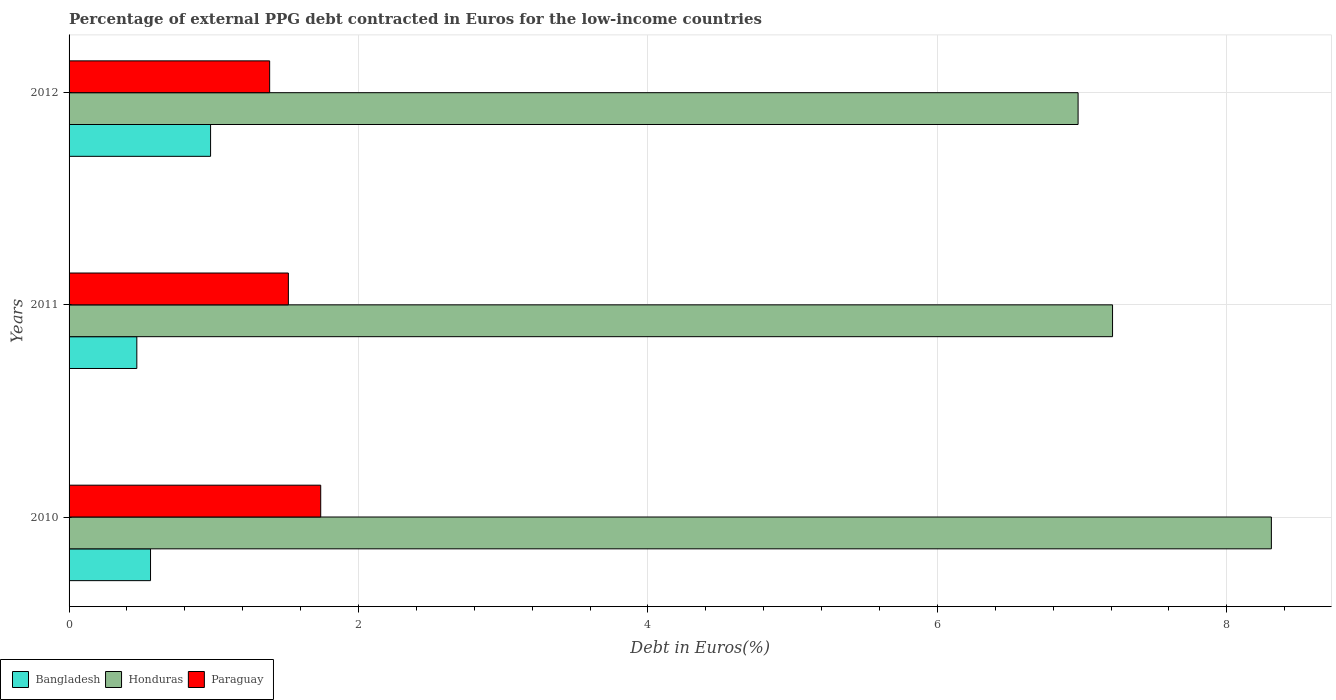How many different coloured bars are there?
Your response must be concise. 3. How many groups of bars are there?
Provide a succinct answer. 3. How many bars are there on the 2nd tick from the top?
Your response must be concise. 3. How many bars are there on the 1st tick from the bottom?
Your response must be concise. 3. What is the percentage of external PPG debt contracted in Euros in Honduras in 2010?
Offer a terse response. 8.31. Across all years, what is the maximum percentage of external PPG debt contracted in Euros in Bangladesh?
Make the answer very short. 0.98. Across all years, what is the minimum percentage of external PPG debt contracted in Euros in Honduras?
Keep it short and to the point. 6.97. What is the total percentage of external PPG debt contracted in Euros in Paraguay in the graph?
Your response must be concise. 4.64. What is the difference between the percentage of external PPG debt contracted in Euros in Honduras in 2011 and that in 2012?
Your response must be concise. 0.24. What is the difference between the percentage of external PPG debt contracted in Euros in Paraguay in 2011 and the percentage of external PPG debt contracted in Euros in Honduras in 2012?
Ensure brevity in your answer.  -5.46. What is the average percentage of external PPG debt contracted in Euros in Paraguay per year?
Offer a very short reply. 1.55. In the year 2012, what is the difference between the percentage of external PPG debt contracted in Euros in Bangladesh and percentage of external PPG debt contracted in Euros in Paraguay?
Your answer should be compact. -0.41. What is the ratio of the percentage of external PPG debt contracted in Euros in Paraguay in 2011 to that in 2012?
Give a very brief answer. 1.09. Is the percentage of external PPG debt contracted in Euros in Bangladesh in 2011 less than that in 2012?
Give a very brief answer. Yes. Is the difference between the percentage of external PPG debt contracted in Euros in Bangladesh in 2011 and 2012 greater than the difference between the percentage of external PPG debt contracted in Euros in Paraguay in 2011 and 2012?
Your answer should be compact. No. What is the difference between the highest and the second highest percentage of external PPG debt contracted in Euros in Paraguay?
Give a very brief answer. 0.22. What is the difference between the highest and the lowest percentage of external PPG debt contracted in Euros in Paraguay?
Keep it short and to the point. 0.35. Is the sum of the percentage of external PPG debt contracted in Euros in Paraguay in 2011 and 2012 greater than the maximum percentage of external PPG debt contracted in Euros in Honduras across all years?
Offer a very short reply. No. What does the 1st bar from the top in 2012 represents?
Your response must be concise. Paraguay. What does the 1st bar from the bottom in 2012 represents?
Provide a succinct answer. Bangladesh. Is it the case that in every year, the sum of the percentage of external PPG debt contracted in Euros in Paraguay and percentage of external PPG debt contracted in Euros in Bangladesh is greater than the percentage of external PPG debt contracted in Euros in Honduras?
Offer a very short reply. No. How many years are there in the graph?
Make the answer very short. 3. What is the difference between two consecutive major ticks on the X-axis?
Provide a succinct answer. 2. Where does the legend appear in the graph?
Your answer should be very brief. Bottom left. How many legend labels are there?
Offer a terse response. 3. How are the legend labels stacked?
Ensure brevity in your answer.  Horizontal. What is the title of the graph?
Your answer should be very brief. Percentage of external PPG debt contracted in Euros for the low-income countries. What is the label or title of the X-axis?
Make the answer very short. Debt in Euros(%). What is the label or title of the Y-axis?
Your answer should be compact. Years. What is the Debt in Euros(%) in Bangladesh in 2010?
Make the answer very short. 0.56. What is the Debt in Euros(%) of Honduras in 2010?
Your response must be concise. 8.31. What is the Debt in Euros(%) of Paraguay in 2010?
Your response must be concise. 1.74. What is the Debt in Euros(%) of Bangladesh in 2011?
Offer a very short reply. 0.47. What is the Debt in Euros(%) in Honduras in 2011?
Provide a succinct answer. 7.21. What is the Debt in Euros(%) in Paraguay in 2011?
Offer a terse response. 1.52. What is the Debt in Euros(%) in Bangladesh in 2012?
Make the answer very short. 0.98. What is the Debt in Euros(%) of Honduras in 2012?
Offer a terse response. 6.97. What is the Debt in Euros(%) in Paraguay in 2012?
Provide a succinct answer. 1.39. Across all years, what is the maximum Debt in Euros(%) of Bangladesh?
Ensure brevity in your answer.  0.98. Across all years, what is the maximum Debt in Euros(%) in Honduras?
Your answer should be compact. 8.31. Across all years, what is the maximum Debt in Euros(%) of Paraguay?
Offer a terse response. 1.74. Across all years, what is the minimum Debt in Euros(%) in Bangladesh?
Your answer should be very brief. 0.47. Across all years, what is the minimum Debt in Euros(%) of Honduras?
Make the answer very short. 6.97. Across all years, what is the minimum Debt in Euros(%) of Paraguay?
Offer a very short reply. 1.39. What is the total Debt in Euros(%) of Bangladesh in the graph?
Make the answer very short. 2.01. What is the total Debt in Euros(%) in Honduras in the graph?
Your answer should be compact. 22.49. What is the total Debt in Euros(%) of Paraguay in the graph?
Keep it short and to the point. 4.64. What is the difference between the Debt in Euros(%) of Bangladesh in 2010 and that in 2011?
Your answer should be compact. 0.09. What is the difference between the Debt in Euros(%) in Honduras in 2010 and that in 2011?
Keep it short and to the point. 1.1. What is the difference between the Debt in Euros(%) of Paraguay in 2010 and that in 2011?
Provide a short and direct response. 0.22. What is the difference between the Debt in Euros(%) of Bangladesh in 2010 and that in 2012?
Keep it short and to the point. -0.41. What is the difference between the Debt in Euros(%) in Honduras in 2010 and that in 2012?
Ensure brevity in your answer.  1.34. What is the difference between the Debt in Euros(%) in Paraguay in 2010 and that in 2012?
Offer a terse response. 0.35. What is the difference between the Debt in Euros(%) of Bangladesh in 2011 and that in 2012?
Offer a terse response. -0.51. What is the difference between the Debt in Euros(%) of Honduras in 2011 and that in 2012?
Your response must be concise. 0.24. What is the difference between the Debt in Euros(%) in Paraguay in 2011 and that in 2012?
Ensure brevity in your answer.  0.13. What is the difference between the Debt in Euros(%) in Bangladesh in 2010 and the Debt in Euros(%) in Honduras in 2011?
Your answer should be compact. -6.65. What is the difference between the Debt in Euros(%) of Bangladesh in 2010 and the Debt in Euros(%) of Paraguay in 2011?
Make the answer very short. -0.95. What is the difference between the Debt in Euros(%) of Honduras in 2010 and the Debt in Euros(%) of Paraguay in 2011?
Offer a terse response. 6.79. What is the difference between the Debt in Euros(%) of Bangladesh in 2010 and the Debt in Euros(%) of Honduras in 2012?
Your answer should be very brief. -6.41. What is the difference between the Debt in Euros(%) in Bangladesh in 2010 and the Debt in Euros(%) in Paraguay in 2012?
Give a very brief answer. -0.82. What is the difference between the Debt in Euros(%) of Honduras in 2010 and the Debt in Euros(%) of Paraguay in 2012?
Make the answer very short. 6.92. What is the difference between the Debt in Euros(%) in Bangladesh in 2011 and the Debt in Euros(%) in Honduras in 2012?
Offer a very short reply. -6.5. What is the difference between the Debt in Euros(%) in Bangladesh in 2011 and the Debt in Euros(%) in Paraguay in 2012?
Your answer should be very brief. -0.92. What is the difference between the Debt in Euros(%) of Honduras in 2011 and the Debt in Euros(%) of Paraguay in 2012?
Offer a very short reply. 5.82. What is the average Debt in Euros(%) of Bangladesh per year?
Give a very brief answer. 0.67. What is the average Debt in Euros(%) in Honduras per year?
Ensure brevity in your answer.  7.5. What is the average Debt in Euros(%) of Paraguay per year?
Keep it short and to the point. 1.55. In the year 2010, what is the difference between the Debt in Euros(%) of Bangladesh and Debt in Euros(%) of Honduras?
Offer a very short reply. -7.75. In the year 2010, what is the difference between the Debt in Euros(%) of Bangladesh and Debt in Euros(%) of Paraguay?
Ensure brevity in your answer.  -1.18. In the year 2010, what is the difference between the Debt in Euros(%) of Honduras and Debt in Euros(%) of Paraguay?
Your answer should be compact. 6.57. In the year 2011, what is the difference between the Debt in Euros(%) in Bangladesh and Debt in Euros(%) in Honduras?
Make the answer very short. -6.74. In the year 2011, what is the difference between the Debt in Euros(%) of Bangladesh and Debt in Euros(%) of Paraguay?
Provide a short and direct response. -1.05. In the year 2011, what is the difference between the Debt in Euros(%) of Honduras and Debt in Euros(%) of Paraguay?
Make the answer very short. 5.7. In the year 2012, what is the difference between the Debt in Euros(%) in Bangladesh and Debt in Euros(%) in Honduras?
Your answer should be very brief. -5.99. In the year 2012, what is the difference between the Debt in Euros(%) of Bangladesh and Debt in Euros(%) of Paraguay?
Your answer should be very brief. -0.41. In the year 2012, what is the difference between the Debt in Euros(%) of Honduras and Debt in Euros(%) of Paraguay?
Your answer should be compact. 5.59. What is the ratio of the Debt in Euros(%) of Bangladesh in 2010 to that in 2011?
Make the answer very short. 1.2. What is the ratio of the Debt in Euros(%) in Honduras in 2010 to that in 2011?
Your answer should be compact. 1.15. What is the ratio of the Debt in Euros(%) of Paraguay in 2010 to that in 2011?
Offer a very short reply. 1.15. What is the ratio of the Debt in Euros(%) in Bangladesh in 2010 to that in 2012?
Ensure brevity in your answer.  0.58. What is the ratio of the Debt in Euros(%) of Honduras in 2010 to that in 2012?
Give a very brief answer. 1.19. What is the ratio of the Debt in Euros(%) of Paraguay in 2010 to that in 2012?
Your response must be concise. 1.25. What is the ratio of the Debt in Euros(%) in Bangladesh in 2011 to that in 2012?
Provide a short and direct response. 0.48. What is the ratio of the Debt in Euros(%) in Honduras in 2011 to that in 2012?
Your answer should be very brief. 1.03. What is the ratio of the Debt in Euros(%) of Paraguay in 2011 to that in 2012?
Your response must be concise. 1.09. What is the difference between the highest and the second highest Debt in Euros(%) of Bangladesh?
Make the answer very short. 0.41. What is the difference between the highest and the second highest Debt in Euros(%) of Honduras?
Make the answer very short. 1.1. What is the difference between the highest and the second highest Debt in Euros(%) of Paraguay?
Provide a short and direct response. 0.22. What is the difference between the highest and the lowest Debt in Euros(%) of Bangladesh?
Your answer should be very brief. 0.51. What is the difference between the highest and the lowest Debt in Euros(%) of Honduras?
Make the answer very short. 1.34. What is the difference between the highest and the lowest Debt in Euros(%) in Paraguay?
Ensure brevity in your answer.  0.35. 